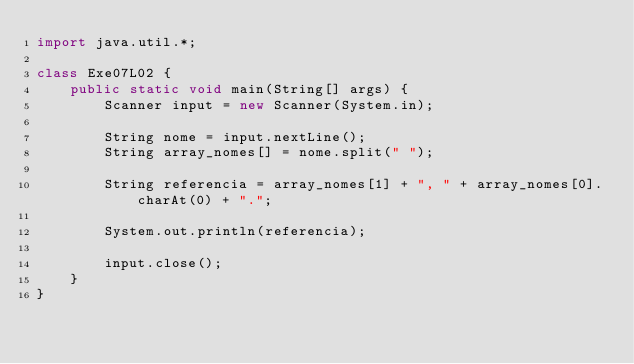<code> <loc_0><loc_0><loc_500><loc_500><_Java_>import java.util.*;

class Exe07L02 {
	public static void main(String[] args) {
		Scanner input = new Scanner(System.in);

		String nome = input.nextLine();
		String array_nomes[] = nome.split(" ");

		String referencia = array_nomes[1] + ", " + array_nomes[0].charAt(0) + ".";

		System.out.println(referencia);

		input.close();
	}
}
</code> 